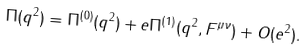Convert formula to latex. <formula><loc_0><loc_0><loc_500><loc_500>\Pi ( q ^ { 2 } ) = \Pi ^ { ( 0 ) } ( q ^ { 2 } ) + e \Pi ^ { ( 1 ) } ( q ^ { 2 } , F ^ { \mu \nu } ) + O ( e ^ { 2 } ) .</formula> 